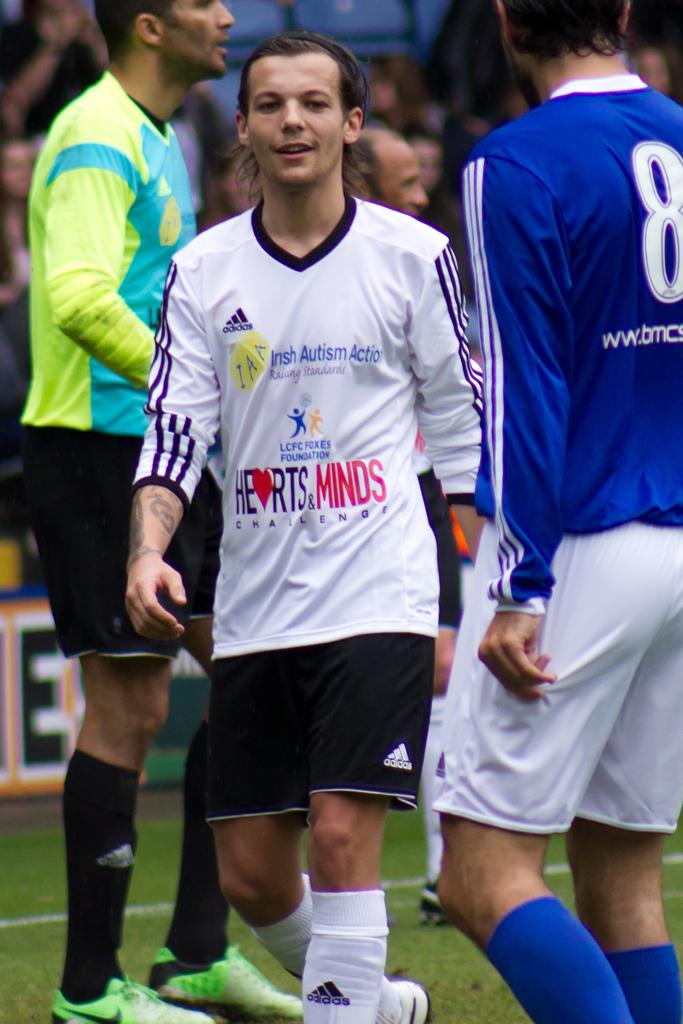What number is the player in the blue jersey wearing?
Keep it short and to the point. 8. What is a sponsor of this game?
Make the answer very short. Hearts & minds. 